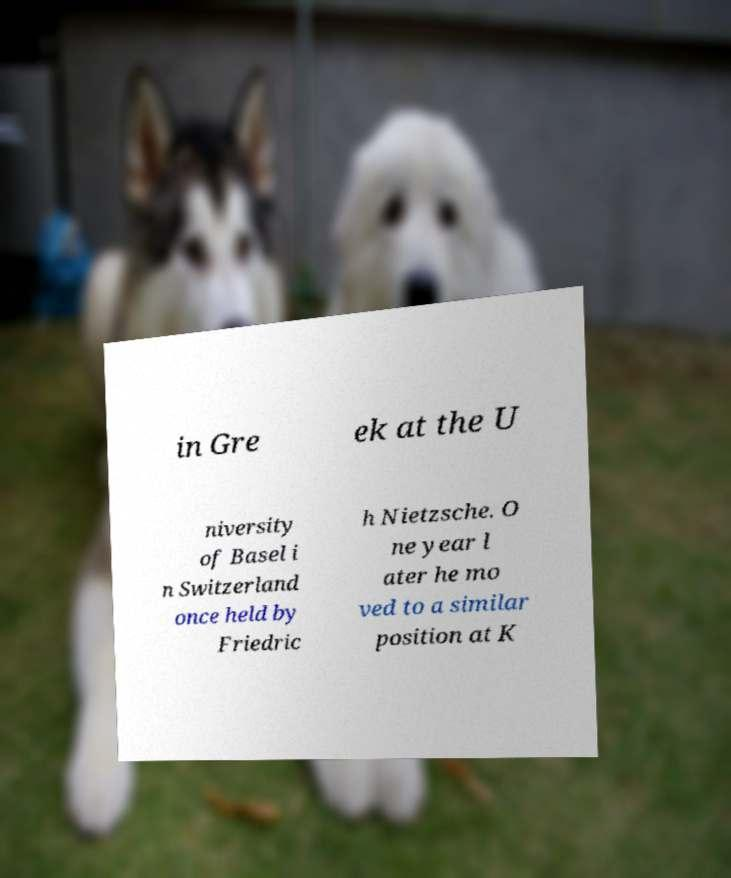Can you accurately transcribe the text from the provided image for me? in Gre ek at the U niversity of Basel i n Switzerland once held by Friedric h Nietzsche. O ne year l ater he mo ved to a similar position at K 